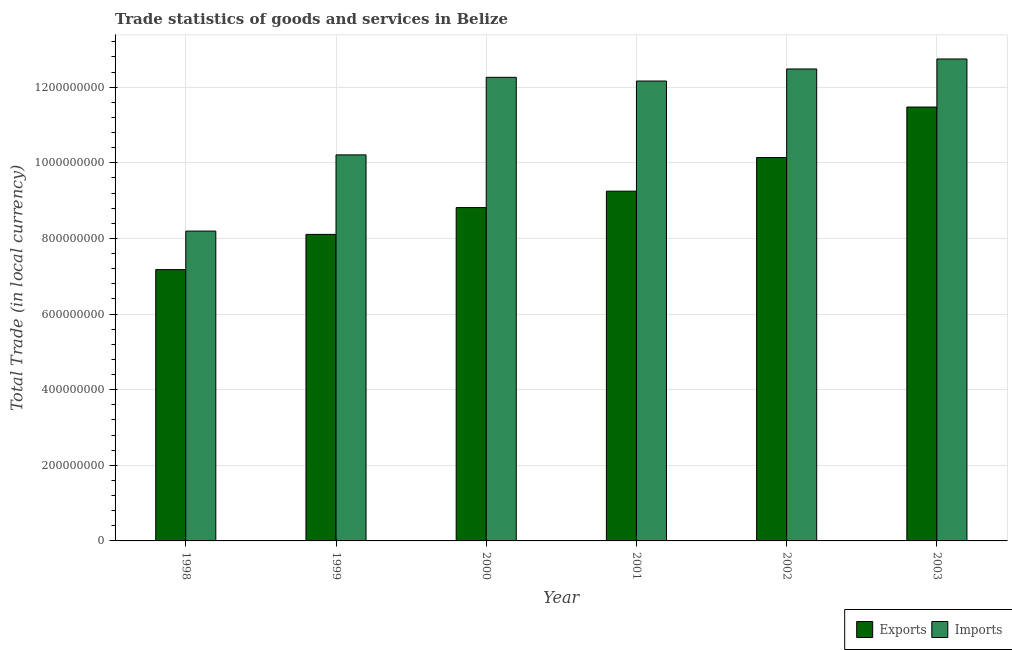Are the number of bars on each tick of the X-axis equal?
Keep it short and to the point. Yes. How many bars are there on the 5th tick from the left?
Ensure brevity in your answer.  2. What is the label of the 4th group of bars from the left?
Give a very brief answer. 2001. What is the imports of goods and services in 2001?
Offer a terse response. 1.22e+09. Across all years, what is the maximum export of goods and services?
Make the answer very short. 1.15e+09. Across all years, what is the minimum export of goods and services?
Your answer should be compact. 7.17e+08. In which year was the export of goods and services maximum?
Your response must be concise. 2003. What is the total export of goods and services in the graph?
Offer a terse response. 5.50e+09. What is the difference between the export of goods and services in 1998 and that in 2003?
Your response must be concise. -4.30e+08. What is the difference between the imports of goods and services in 2000 and the export of goods and services in 1999?
Ensure brevity in your answer.  2.05e+08. What is the average imports of goods and services per year?
Your response must be concise. 1.13e+09. What is the ratio of the export of goods and services in 1999 to that in 2002?
Give a very brief answer. 0.8. Is the difference between the export of goods and services in 1999 and 2001 greater than the difference between the imports of goods and services in 1999 and 2001?
Provide a succinct answer. No. What is the difference between the highest and the second highest imports of goods and services?
Provide a succinct answer. 2.64e+07. What is the difference between the highest and the lowest imports of goods and services?
Keep it short and to the point. 4.55e+08. In how many years, is the export of goods and services greater than the average export of goods and services taken over all years?
Give a very brief answer. 3. Is the sum of the imports of goods and services in 2002 and 2003 greater than the maximum export of goods and services across all years?
Keep it short and to the point. Yes. What does the 1st bar from the left in 1998 represents?
Your answer should be compact. Exports. What does the 2nd bar from the right in 2000 represents?
Ensure brevity in your answer.  Exports. How many bars are there?
Your answer should be very brief. 12. How many years are there in the graph?
Offer a terse response. 6. Are the values on the major ticks of Y-axis written in scientific E-notation?
Provide a succinct answer. No. Where does the legend appear in the graph?
Ensure brevity in your answer.  Bottom right. What is the title of the graph?
Your answer should be compact. Trade statistics of goods and services in Belize. What is the label or title of the X-axis?
Provide a short and direct response. Year. What is the label or title of the Y-axis?
Offer a terse response. Total Trade (in local currency). What is the Total Trade (in local currency) in Exports in 1998?
Keep it short and to the point. 7.17e+08. What is the Total Trade (in local currency) in Imports in 1998?
Offer a very short reply. 8.19e+08. What is the Total Trade (in local currency) in Exports in 1999?
Offer a very short reply. 8.11e+08. What is the Total Trade (in local currency) in Imports in 1999?
Ensure brevity in your answer.  1.02e+09. What is the Total Trade (in local currency) of Exports in 2000?
Make the answer very short. 8.82e+08. What is the Total Trade (in local currency) of Imports in 2000?
Keep it short and to the point. 1.23e+09. What is the Total Trade (in local currency) in Exports in 2001?
Ensure brevity in your answer.  9.25e+08. What is the Total Trade (in local currency) in Imports in 2001?
Your response must be concise. 1.22e+09. What is the Total Trade (in local currency) in Exports in 2002?
Your answer should be compact. 1.01e+09. What is the Total Trade (in local currency) of Imports in 2002?
Make the answer very short. 1.25e+09. What is the Total Trade (in local currency) of Exports in 2003?
Your answer should be very brief. 1.15e+09. What is the Total Trade (in local currency) in Imports in 2003?
Keep it short and to the point. 1.27e+09. Across all years, what is the maximum Total Trade (in local currency) of Exports?
Provide a succinct answer. 1.15e+09. Across all years, what is the maximum Total Trade (in local currency) in Imports?
Offer a terse response. 1.27e+09. Across all years, what is the minimum Total Trade (in local currency) in Exports?
Your response must be concise. 7.17e+08. Across all years, what is the minimum Total Trade (in local currency) of Imports?
Your answer should be compact. 8.19e+08. What is the total Total Trade (in local currency) of Exports in the graph?
Provide a short and direct response. 5.50e+09. What is the total Total Trade (in local currency) of Imports in the graph?
Your answer should be very brief. 6.81e+09. What is the difference between the Total Trade (in local currency) of Exports in 1998 and that in 1999?
Provide a succinct answer. -9.31e+07. What is the difference between the Total Trade (in local currency) of Imports in 1998 and that in 1999?
Provide a short and direct response. -2.02e+08. What is the difference between the Total Trade (in local currency) in Exports in 1998 and that in 2000?
Provide a short and direct response. -1.64e+08. What is the difference between the Total Trade (in local currency) in Imports in 1998 and that in 2000?
Keep it short and to the point. -4.07e+08. What is the difference between the Total Trade (in local currency) in Exports in 1998 and that in 2001?
Provide a short and direct response. -2.07e+08. What is the difference between the Total Trade (in local currency) in Imports in 1998 and that in 2001?
Keep it short and to the point. -3.97e+08. What is the difference between the Total Trade (in local currency) in Exports in 1998 and that in 2002?
Keep it short and to the point. -2.96e+08. What is the difference between the Total Trade (in local currency) in Imports in 1998 and that in 2002?
Offer a terse response. -4.29e+08. What is the difference between the Total Trade (in local currency) in Exports in 1998 and that in 2003?
Keep it short and to the point. -4.30e+08. What is the difference between the Total Trade (in local currency) in Imports in 1998 and that in 2003?
Give a very brief answer. -4.55e+08. What is the difference between the Total Trade (in local currency) of Exports in 1999 and that in 2000?
Make the answer very short. -7.09e+07. What is the difference between the Total Trade (in local currency) of Imports in 1999 and that in 2000?
Your answer should be compact. -2.05e+08. What is the difference between the Total Trade (in local currency) in Exports in 1999 and that in 2001?
Offer a terse response. -1.14e+08. What is the difference between the Total Trade (in local currency) in Imports in 1999 and that in 2001?
Provide a short and direct response. -1.95e+08. What is the difference between the Total Trade (in local currency) in Exports in 1999 and that in 2002?
Make the answer very short. -2.03e+08. What is the difference between the Total Trade (in local currency) in Imports in 1999 and that in 2002?
Your answer should be compact. -2.27e+08. What is the difference between the Total Trade (in local currency) in Exports in 1999 and that in 2003?
Make the answer very short. -3.37e+08. What is the difference between the Total Trade (in local currency) of Imports in 1999 and that in 2003?
Provide a short and direct response. -2.54e+08. What is the difference between the Total Trade (in local currency) in Exports in 2000 and that in 2001?
Give a very brief answer. -4.34e+07. What is the difference between the Total Trade (in local currency) of Imports in 2000 and that in 2001?
Offer a terse response. 9.80e+06. What is the difference between the Total Trade (in local currency) in Exports in 2000 and that in 2002?
Offer a very short reply. -1.32e+08. What is the difference between the Total Trade (in local currency) in Imports in 2000 and that in 2002?
Offer a terse response. -2.21e+07. What is the difference between the Total Trade (in local currency) of Exports in 2000 and that in 2003?
Your response must be concise. -2.66e+08. What is the difference between the Total Trade (in local currency) of Imports in 2000 and that in 2003?
Give a very brief answer. -4.85e+07. What is the difference between the Total Trade (in local currency) in Exports in 2001 and that in 2002?
Keep it short and to the point. -8.90e+07. What is the difference between the Total Trade (in local currency) in Imports in 2001 and that in 2002?
Your response must be concise. -3.19e+07. What is the difference between the Total Trade (in local currency) of Exports in 2001 and that in 2003?
Give a very brief answer. -2.22e+08. What is the difference between the Total Trade (in local currency) of Imports in 2001 and that in 2003?
Your response must be concise. -5.83e+07. What is the difference between the Total Trade (in local currency) in Exports in 2002 and that in 2003?
Your answer should be very brief. -1.34e+08. What is the difference between the Total Trade (in local currency) of Imports in 2002 and that in 2003?
Give a very brief answer. -2.64e+07. What is the difference between the Total Trade (in local currency) of Exports in 1998 and the Total Trade (in local currency) of Imports in 1999?
Offer a very short reply. -3.03e+08. What is the difference between the Total Trade (in local currency) in Exports in 1998 and the Total Trade (in local currency) in Imports in 2000?
Your response must be concise. -5.09e+08. What is the difference between the Total Trade (in local currency) of Exports in 1998 and the Total Trade (in local currency) of Imports in 2001?
Offer a very short reply. -4.99e+08. What is the difference between the Total Trade (in local currency) in Exports in 1998 and the Total Trade (in local currency) in Imports in 2002?
Give a very brief answer. -5.31e+08. What is the difference between the Total Trade (in local currency) of Exports in 1998 and the Total Trade (in local currency) of Imports in 2003?
Give a very brief answer. -5.57e+08. What is the difference between the Total Trade (in local currency) in Exports in 1999 and the Total Trade (in local currency) in Imports in 2000?
Provide a short and direct response. -4.15e+08. What is the difference between the Total Trade (in local currency) of Exports in 1999 and the Total Trade (in local currency) of Imports in 2001?
Provide a succinct answer. -4.06e+08. What is the difference between the Total Trade (in local currency) in Exports in 1999 and the Total Trade (in local currency) in Imports in 2002?
Offer a very short reply. -4.37e+08. What is the difference between the Total Trade (in local currency) in Exports in 1999 and the Total Trade (in local currency) in Imports in 2003?
Ensure brevity in your answer.  -4.64e+08. What is the difference between the Total Trade (in local currency) in Exports in 2000 and the Total Trade (in local currency) in Imports in 2001?
Provide a succinct answer. -3.35e+08. What is the difference between the Total Trade (in local currency) of Exports in 2000 and the Total Trade (in local currency) of Imports in 2002?
Your response must be concise. -3.67e+08. What is the difference between the Total Trade (in local currency) of Exports in 2000 and the Total Trade (in local currency) of Imports in 2003?
Your answer should be compact. -3.93e+08. What is the difference between the Total Trade (in local currency) of Exports in 2001 and the Total Trade (in local currency) of Imports in 2002?
Your response must be concise. -3.23e+08. What is the difference between the Total Trade (in local currency) of Exports in 2001 and the Total Trade (in local currency) of Imports in 2003?
Your response must be concise. -3.50e+08. What is the difference between the Total Trade (in local currency) in Exports in 2002 and the Total Trade (in local currency) in Imports in 2003?
Provide a short and direct response. -2.61e+08. What is the average Total Trade (in local currency) of Exports per year?
Your response must be concise. 9.16e+08. What is the average Total Trade (in local currency) of Imports per year?
Ensure brevity in your answer.  1.13e+09. In the year 1998, what is the difference between the Total Trade (in local currency) of Exports and Total Trade (in local currency) of Imports?
Your answer should be very brief. -1.02e+08. In the year 1999, what is the difference between the Total Trade (in local currency) of Exports and Total Trade (in local currency) of Imports?
Offer a very short reply. -2.10e+08. In the year 2000, what is the difference between the Total Trade (in local currency) of Exports and Total Trade (in local currency) of Imports?
Offer a very short reply. -3.44e+08. In the year 2001, what is the difference between the Total Trade (in local currency) of Exports and Total Trade (in local currency) of Imports?
Give a very brief answer. -2.91e+08. In the year 2002, what is the difference between the Total Trade (in local currency) in Exports and Total Trade (in local currency) in Imports?
Provide a succinct answer. -2.34e+08. In the year 2003, what is the difference between the Total Trade (in local currency) of Exports and Total Trade (in local currency) of Imports?
Make the answer very short. -1.27e+08. What is the ratio of the Total Trade (in local currency) of Exports in 1998 to that in 1999?
Keep it short and to the point. 0.89. What is the ratio of the Total Trade (in local currency) of Imports in 1998 to that in 1999?
Offer a terse response. 0.8. What is the ratio of the Total Trade (in local currency) of Exports in 1998 to that in 2000?
Your response must be concise. 0.81. What is the ratio of the Total Trade (in local currency) of Imports in 1998 to that in 2000?
Ensure brevity in your answer.  0.67. What is the ratio of the Total Trade (in local currency) of Exports in 1998 to that in 2001?
Your response must be concise. 0.78. What is the ratio of the Total Trade (in local currency) of Imports in 1998 to that in 2001?
Give a very brief answer. 0.67. What is the ratio of the Total Trade (in local currency) of Exports in 1998 to that in 2002?
Keep it short and to the point. 0.71. What is the ratio of the Total Trade (in local currency) of Imports in 1998 to that in 2002?
Provide a short and direct response. 0.66. What is the ratio of the Total Trade (in local currency) in Exports in 1998 to that in 2003?
Make the answer very short. 0.63. What is the ratio of the Total Trade (in local currency) in Imports in 1998 to that in 2003?
Provide a succinct answer. 0.64. What is the ratio of the Total Trade (in local currency) in Exports in 1999 to that in 2000?
Offer a very short reply. 0.92. What is the ratio of the Total Trade (in local currency) of Imports in 1999 to that in 2000?
Your response must be concise. 0.83. What is the ratio of the Total Trade (in local currency) of Exports in 1999 to that in 2001?
Offer a very short reply. 0.88. What is the ratio of the Total Trade (in local currency) of Imports in 1999 to that in 2001?
Ensure brevity in your answer.  0.84. What is the ratio of the Total Trade (in local currency) in Exports in 1999 to that in 2002?
Ensure brevity in your answer.  0.8. What is the ratio of the Total Trade (in local currency) in Imports in 1999 to that in 2002?
Provide a succinct answer. 0.82. What is the ratio of the Total Trade (in local currency) of Exports in 1999 to that in 2003?
Your answer should be compact. 0.71. What is the ratio of the Total Trade (in local currency) of Imports in 1999 to that in 2003?
Your answer should be very brief. 0.8. What is the ratio of the Total Trade (in local currency) of Exports in 2000 to that in 2001?
Give a very brief answer. 0.95. What is the ratio of the Total Trade (in local currency) of Imports in 2000 to that in 2001?
Make the answer very short. 1.01. What is the ratio of the Total Trade (in local currency) in Exports in 2000 to that in 2002?
Your response must be concise. 0.87. What is the ratio of the Total Trade (in local currency) of Imports in 2000 to that in 2002?
Keep it short and to the point. 0.98. What is the ratio of the Total Trade (in local currency) of Exports in 2000 to that in 2003?
Your answer should be very brief. 0.77. What is the ratio of the Total Trade (in local currency) of Imports in 2000 to that in 2003?
Make the answer very short. 0.96. What is the ratio of the Total Trade (in local currency) of Exports in 2001 to that in 2002?
Provide a succinct answer. 0.91. What is the ratio of the Total Trade (in local currency) in Imports in 2001 to that in 2002?
Provide a succinct answer. 0.97. What is the ratio of the Total Trade (in local currency) of Exports in 2001 to that in 2003?
Your response must be concise. 0.81. What is the ratio of the Total Trade (in local currency) in Imports in 2001 to that in 2003?
Your answer should be compact. 0.95. What is the ratio of the Total Trade (in local currency) of Exports in 2002 to that in 2003?
Your response must be concise. 0.88. What is the ratio of the Total Trade (in local currency) of Imports in 2002 to that in 2003?
Your answer should be very brief. 0.98. What is the difference between the highest and the second highest Total Trade (in local currency) of Exports?
Ensure brevity in your answer.  1.34e+08. What is the difference between the highest and the second highest Total Trade (in local currency) of Imports?
Your answer should be compact. 2.64e+07. What is the difference between the highest and the lowest Total Trade (in local currency) in Exports?
Offer a very short reply. 4.30e+08. What is the difference between the highest and the lowest Total Trade (in local currency) in Imports?
Your answer should be compact. 4.55e+08. 